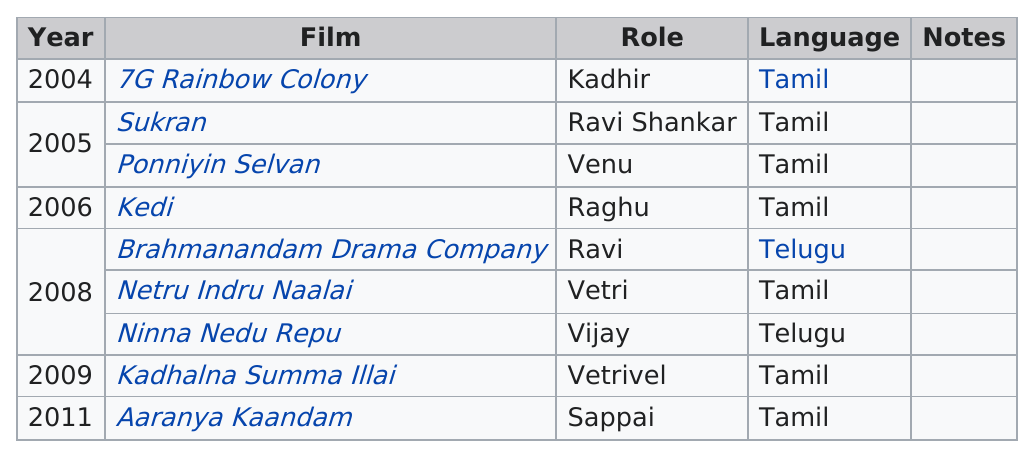Identify some key points in this picture. There are four roles that start with the letter 'v'. In 2008, three films were produced. There are 2 films in Telugu. In 2008, there were more films than in 2005. I declare that Sukran is older than Kedi. 